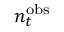Convert formula to latex. <formula><loc_0><loc_0><loc_500><loc_500>n _ { t } ^ { o b s }</formula> 